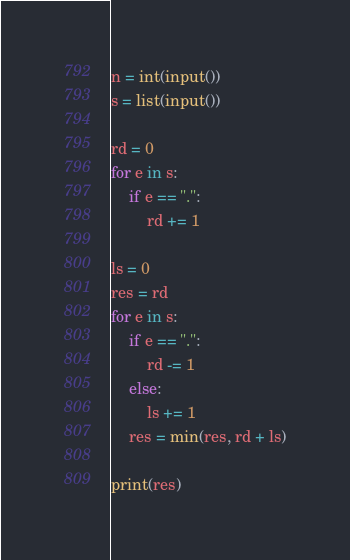Convert code to text. <code><loc_0><loc_0><loc_500><loc_500><_Python_>n = int(input())
s = list(input())

rd = 0
for e in s:
    if e == ".":
        rd += 1

ls = 0
res = rd
for e in s:
    if e == ".":
        rd -= 1
    else:
        ls += 1
    res = min(res, rd + ls)

print(res)
</code> 